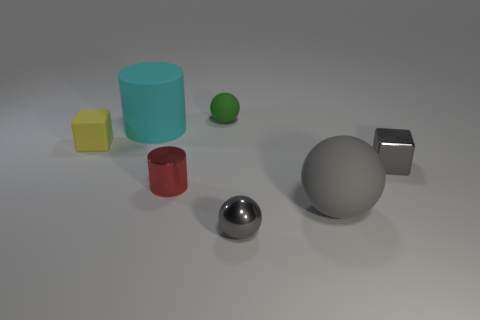Subtract all small green balls. How many balls are left? 2 Add 2 tiny green rubber spheres. How many objects exist? 9 Subtract 2 spheres. How many spheres are left? 1 Subtract all green balls. How many balls are left? 2 Subtract all cylinders. How many objects are left? 5 Subtract all cyan cylinders. How many gray cubes are left? 1 Subtract all purple metallic objects. Subtract all shiny objects. How many objects are left? 4 Add 6 cyan cylinders. How many cyan cylinders are left? 7 Add 2 blocks. How many blocks exist? 4 Subtract 0 blue blocks. How many objects are left? 7 